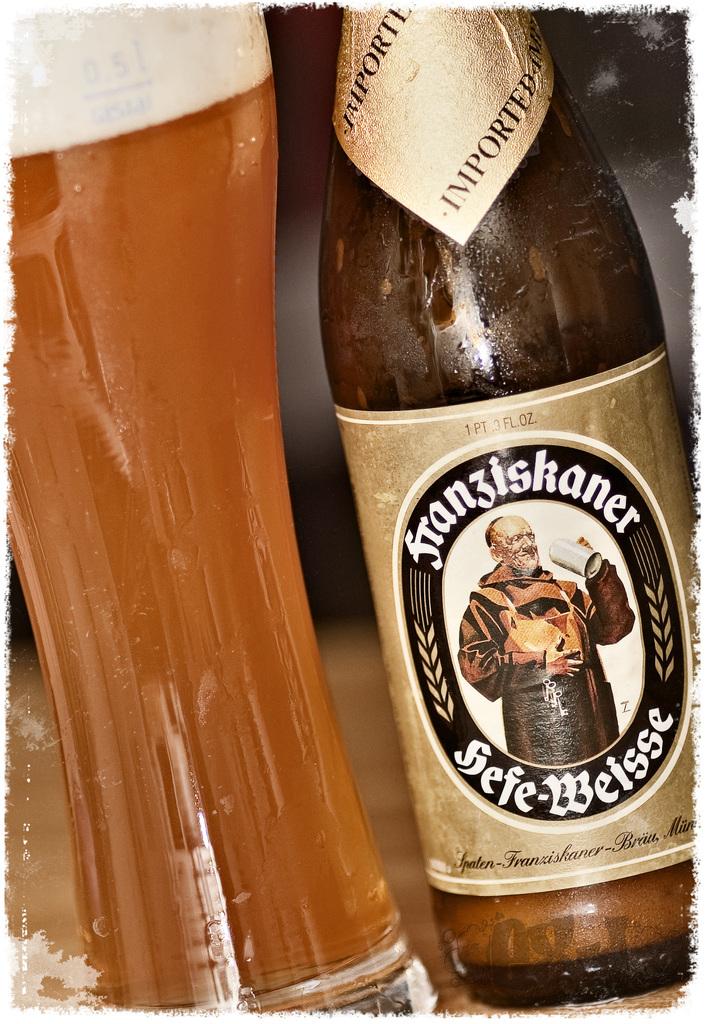What is the name of the beer?
Your answer should be very brief. Franziskaner. 